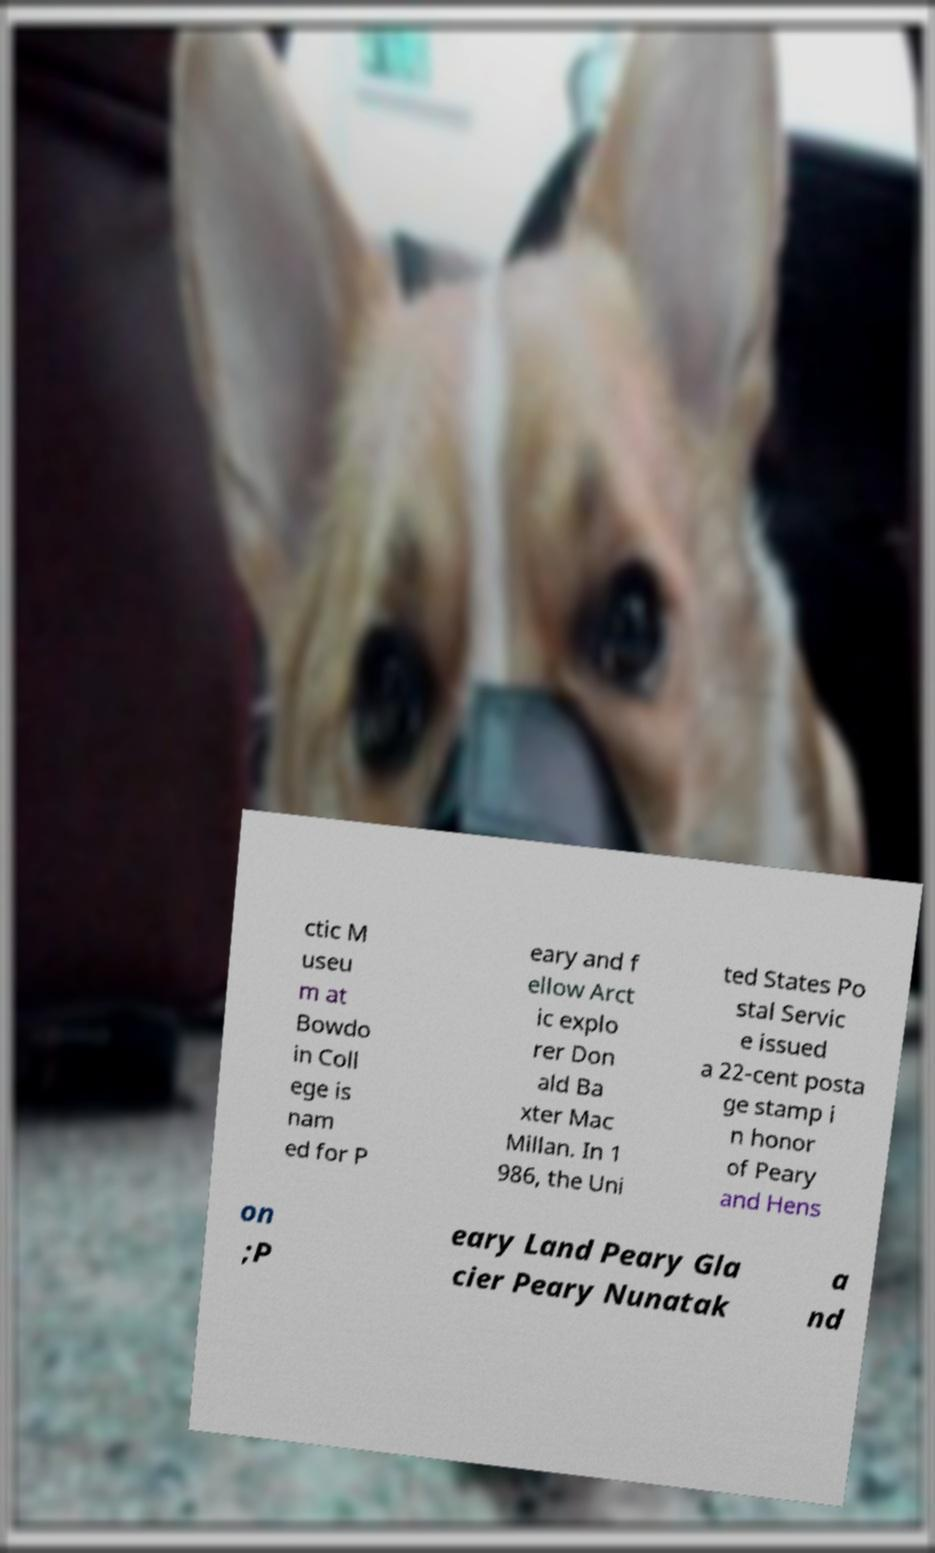I need the written content from this picture converted into text. Can you do that? ctic M useu m at Bowdo in Coll ege is nam ed for P eary and f ellow Arct ic explo rer Don ald Ba xter Mac Millan. In 1 986, the Uni ted States Po stal Servic e issued a 22-cent posta ge stamp i n honor of Peary and Hens on ;P eary Land Peary Gla cier Peary Nunatak a nd 